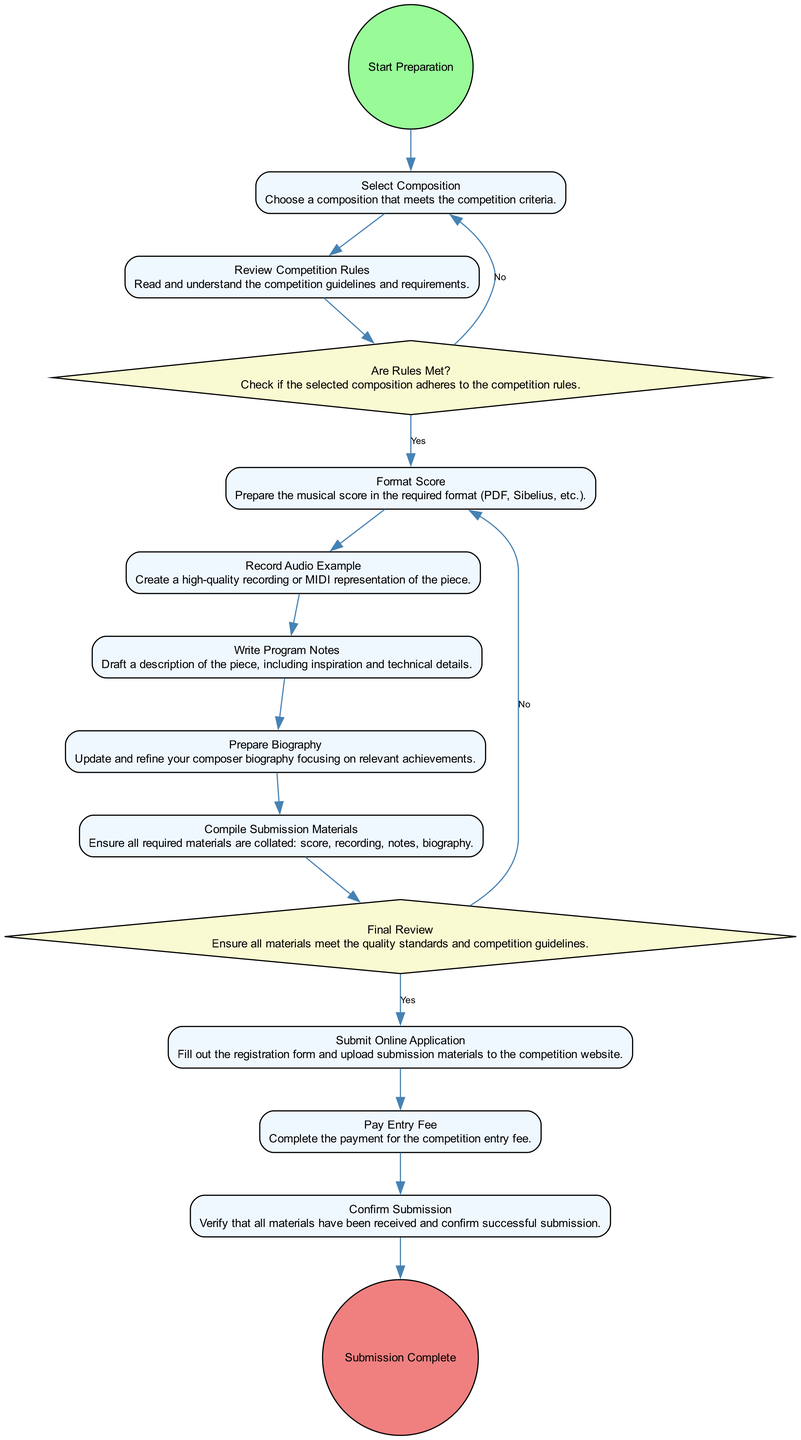what is the starting point of the activity diagram? The starting point of the diagram is labeled "Start Preparation," indicating where the process begins.
Answer: Start Preparation how many activities are there in the diagram? By counting the individual activity nodes, there are a total of 10 activities listed, which outline the steps involved in preparing and submitting music for the competition.
Answer: 10 which activity comes immediately after the "Review Competition Rules"? Following the "Review Competition Rules" activity, the next activity in the flow is "Format Score." This indicates the order of tasks after understanding the competition's criteria.
Answer: Format Score what happens if the rules are not met during the selection of the composition? If the rules are not met, the flow goes back to the "Select Composition" node, indicating that the composer must choose a different piece that complies with the guidelines.
Answer: Select Composition which decision point is related to the quality of submission materials? The decision point labeled "Final Review" assesses whether all materials meet the quality standards and competition guidelines before proceeding to submission.
Answer: Final Review what is the final step in the activity diagram? The final step in the process is labeled "Submission Complete," which signifies that the submission process has been finished successfully after all prior activities.
Answer: Submission Complete which activity directly precedes the "Submit Online Application"? The activity that directly precedes "Submit Online Application" is "Compile Submission Materials." This step involves gathering all the necessary documentation before final submission.
Answer: Compile Submission Materials how many decision points are there in this activity diagram? There are a total of 2 decision points in the diagram, each serving to evaluate crucial aspects of the submission process.
Answer: 2 what is the outcome of a negative result in the final review? A negative result in the "Final Review" leads back to the "Format Score" step, indicating that the materials need further refinement before submission.
Answer: Format Score 